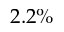Convert formula to latex. <formula><loc_0><loc_0><loc_500><loc_500>2 . 2 \%</formula> 